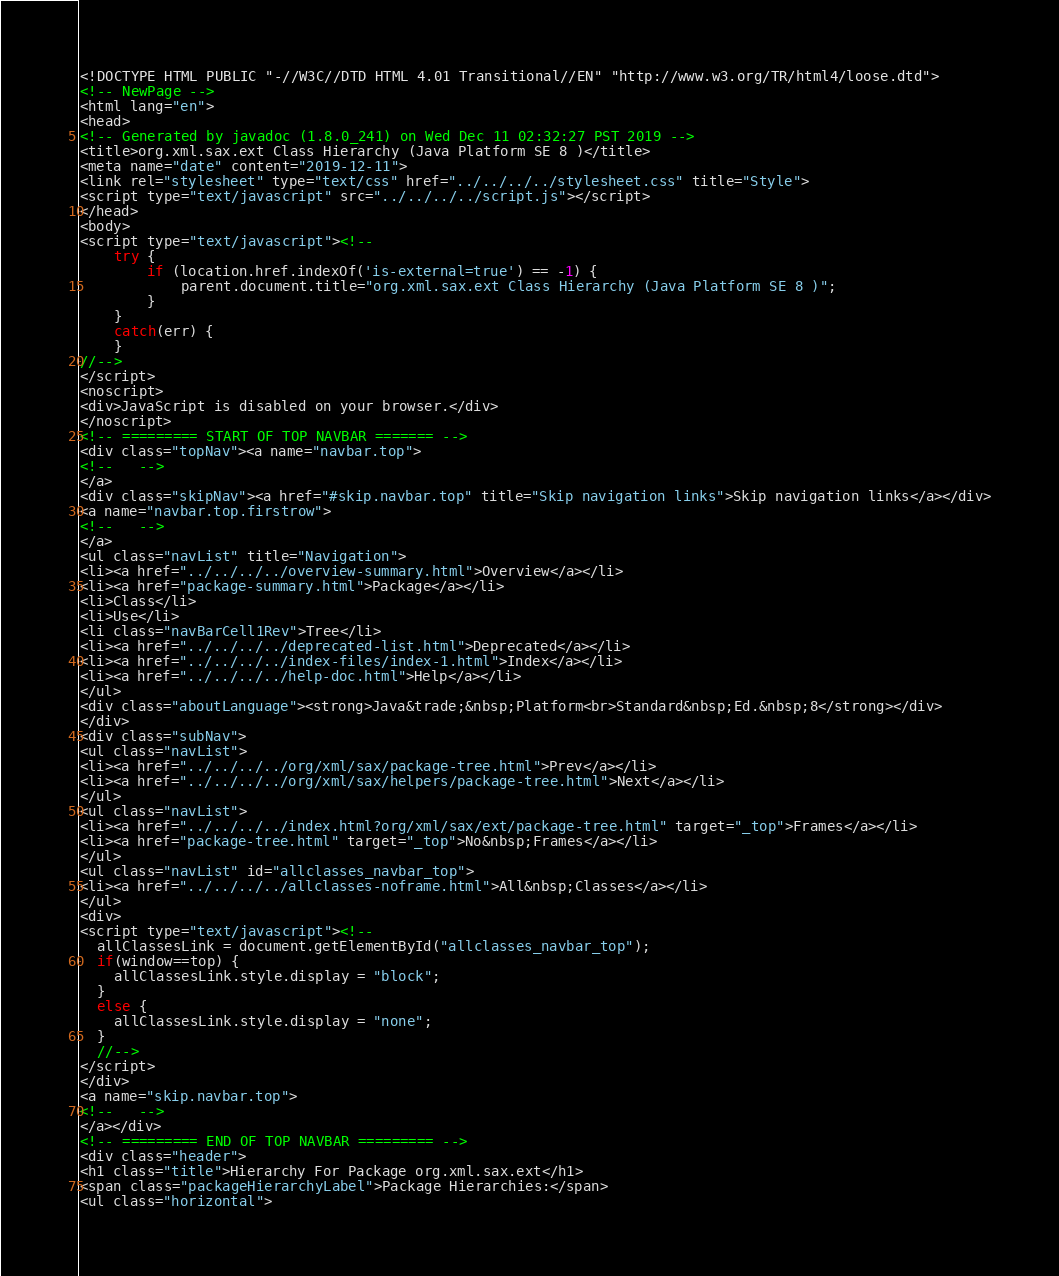<code> <loc_0><loc_0><loc_500><loc_500><_HTML_><!DOCTYPE HTML PUBLIC "-//W3C//DTD HTML 4.01 Transitional//EN" "http://www.w3.org/TR/html4/loose.dtd">
<!-- NewPage -->
<html lang="en">
<head>
<!-- Generated by javadoc (1.8.0_241) on Wed Dec 11 02:32:27 PST 2019 -->
<title>org.xml.sax.ext Class Hierarchy (Java Platform SE 8 )</title>
<meta name="date" content="2019-12-11">
<link rel="stylesheet" type="text/css" href="../../../../stylesheet.css" title="Style">
<script type="text/javascript" src="../../../../script.js"></script>
</head>
<body>
<script type="text/javascript"><!--
    try {
        if (location.href.indexOf('is-external=true') == -1) {
            parent.document.title="org.xml.sax.ext Class Hierarchy (Java Platform SE 8 )";
        }
    }
    catch(err) {
    }
//-->
</script>
<noscript>
<div>JavaScript is disabled on your browser.</div>
</noscript>
<!-- ========= START OF TOP NAVBAR ======= -->
<div class="topNav"><a name="navbar.top">
<!--   -->
</a>
<div class="skipNav"><a href="#skip.navbar.top" title="Skip navigation links">Skip navigation links</a></div>
<a name="navbar.top.firstrow">
<!--   -->
</a>
<ul class="navList" title="Navigation">
<li><a href="../../../../overview-summary.html">Overview</a></li>
<li><a href="package-summary.html">Package</a></li>
<li>Class</li>
<li>Use</li>
<li class="navBarCell1Rev">Tree</li>
<li><a href="../../../../deprecated-list.html">Deprecated</a></li>
<li><a href="../../../../index-files/index-1.html">Index</a></li>
<li><a href="../../../../help-doc.html">Help</a></li>
</ul>
<div class="aboutLanguage"><strong>Java&trade;&nbsp;Platform<br>Standard&nbsp;Ed.&nbsp;8</strong></div>
</div>
<div class="subNav">
<ul class="navList">
<li><a href="../../../../org/xml/sax/package-tree.html">Prev</a></li>
<li><a href="../../../../org/xml/sax/helpers/package-tree.html">Next</a></li>
</ul>
<ul class="navList">
<li><a href="../../../../index.html?org/xml/sax/ext/package-tree.html" target="_top">Frames</a></li>
<li><a href="package-tree.html" target="_top">No&nbsp;Frames</a></li>
</ul>
<ul class="navList" id="allclasses_navbar_top">
<li><a href="../../../../allclasses-noframe.html">All&nbsp;Classes</a></li>
</ul>
<div>
<script type="text/javascript"><!--
  allClassesLink = document.getElementById("allclasses_navbar_top");
  if(window==top) {
    allClassesLink.style.display = "block";
  }
  else {
    allClassesLink.style.display = "none";
  }
  //-->
</script>
</div>
<a name="skip.navbar.top">
<!--   -->
</a></div>
<!-- ========= END OF TOP NAVBAR ========= -->
<div class="header">
<h1 class="title">Hierarchy For Package org.xml.sax.ext</h1>
<span class="packageHierarchyLabel">Package Hierarchies:</span>
<ul class="horizontal"></code> 